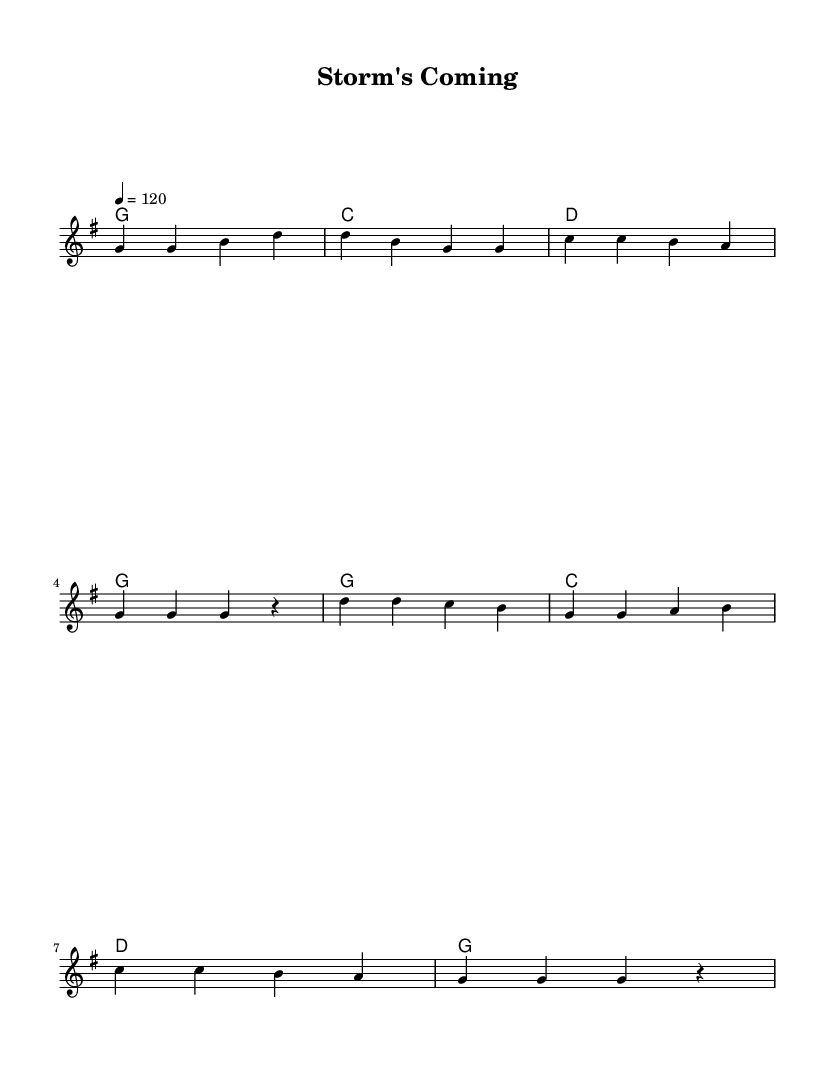What is the key signature of this music? The key signature is G major, which has one sharp (F#). This can be determined from the key indication present at the beginning of the score.
Answer: G major What is the time signature of this music? The time signature is 4/4, which indicates there are four beats per measure and the quarter note gets one beat. This is explicitly shown in the sheet music at the beginning.
Answer: 4/4 What is the tempo marking in this piece? The tempo marking is 120 beats per minute, indicated by the annotation "4 = 120" at the beginning. This means that the quarter notes are played at a speed of 120 beats per minute.
Answer: 120 How many measures are in the verse of the song? The verse consists of four measures, which can be counted from the musical notation provided before the first chorus. Each set of four beats represents a single measure.
Answer: 4 What emotion does the song's lyrics convey? The lyrics convey preparedness and concern, as indicated by lines expressing urgency and the need to prepare for an impending storm. The context of the lyrics reflects on taking action before a disaster strikes.
Answer: Urgency How does the chorus relate to the verse in theme? The chorus emphasizes the message of being prepared, echoing the sentiment of the verses where it discusses gathering information and materials in anticipation of a storm. This thematic connection reinforces the song's overall message of disaster preparedness.
Answer: Preparedness 